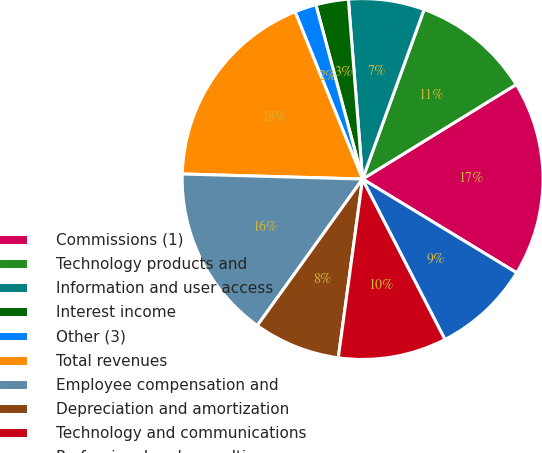Convert chart. <chart><loc_0><loc_0><loc_500><loc_500><pie_chart><fcel>Commissions (1)<fcel>Technology products and<fcel>Information and user access<fcel>Interest income<fcel>Other (3)<fcel>Total revenues<fcel>Employee compensation and<fcel>Depreciation and amortization<fcel>Technology and communications<fcel>Professional and consulting<nl><fcel>17.48%<fcel>10.68%<fcel>6.8%<fcel>2.91%<fcel>1.94%<fcel>18.45%<fcel>15.53%<fcel>7.77%<fcel>9.71%<fcel>8.74%<nl></chart> 